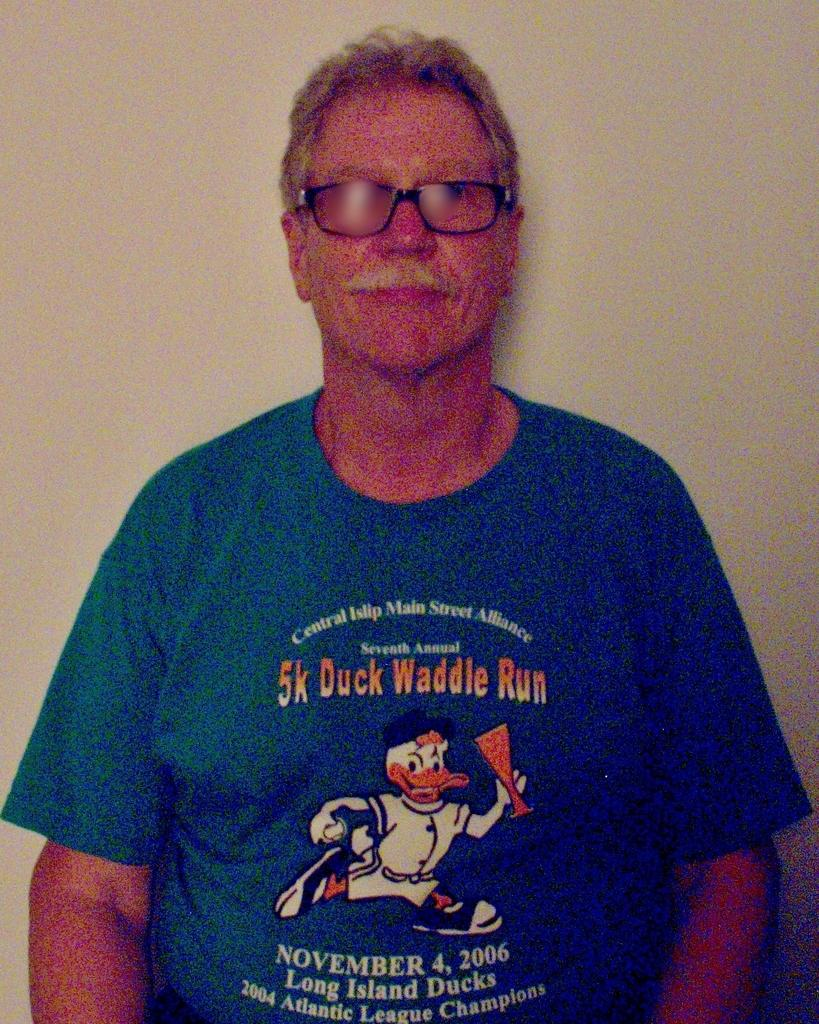What is the main subject of the picture? The main subject of the picture is a man. Where is the man located in the image? The man is standing near a wall in the image. What is the man wearing? The man is wearing a blue T-shirt in the image. What is depicted on the T-shirt? The T-shirt has a cartoon image on it. Can you describe the man's facial hair? The man has a white mustache in the image. How many cars are parked near the man in the image? There are no cars visible in the image; it only features a man standing near a wall. What type of apple is the man holding in the image? There is no apple present in the image. 